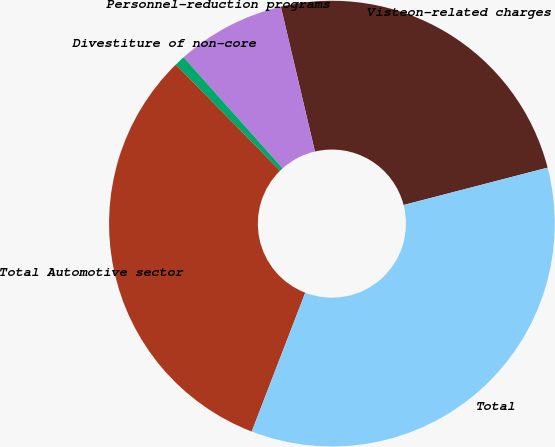<chart> <loc_0><loc_0><loc_500><loc_500><pie_chart><fcel>Visteon-related charges<fcel>Personnel-reduction programs<fcel>Divestiture of non-core<fcel>Total Automotive sector<fcel>Total<nl><fcel>24.64%<fcel>7.91%<fcel>0.76%<fcel>31.79%<fcel>34.9%<nl></chart> 